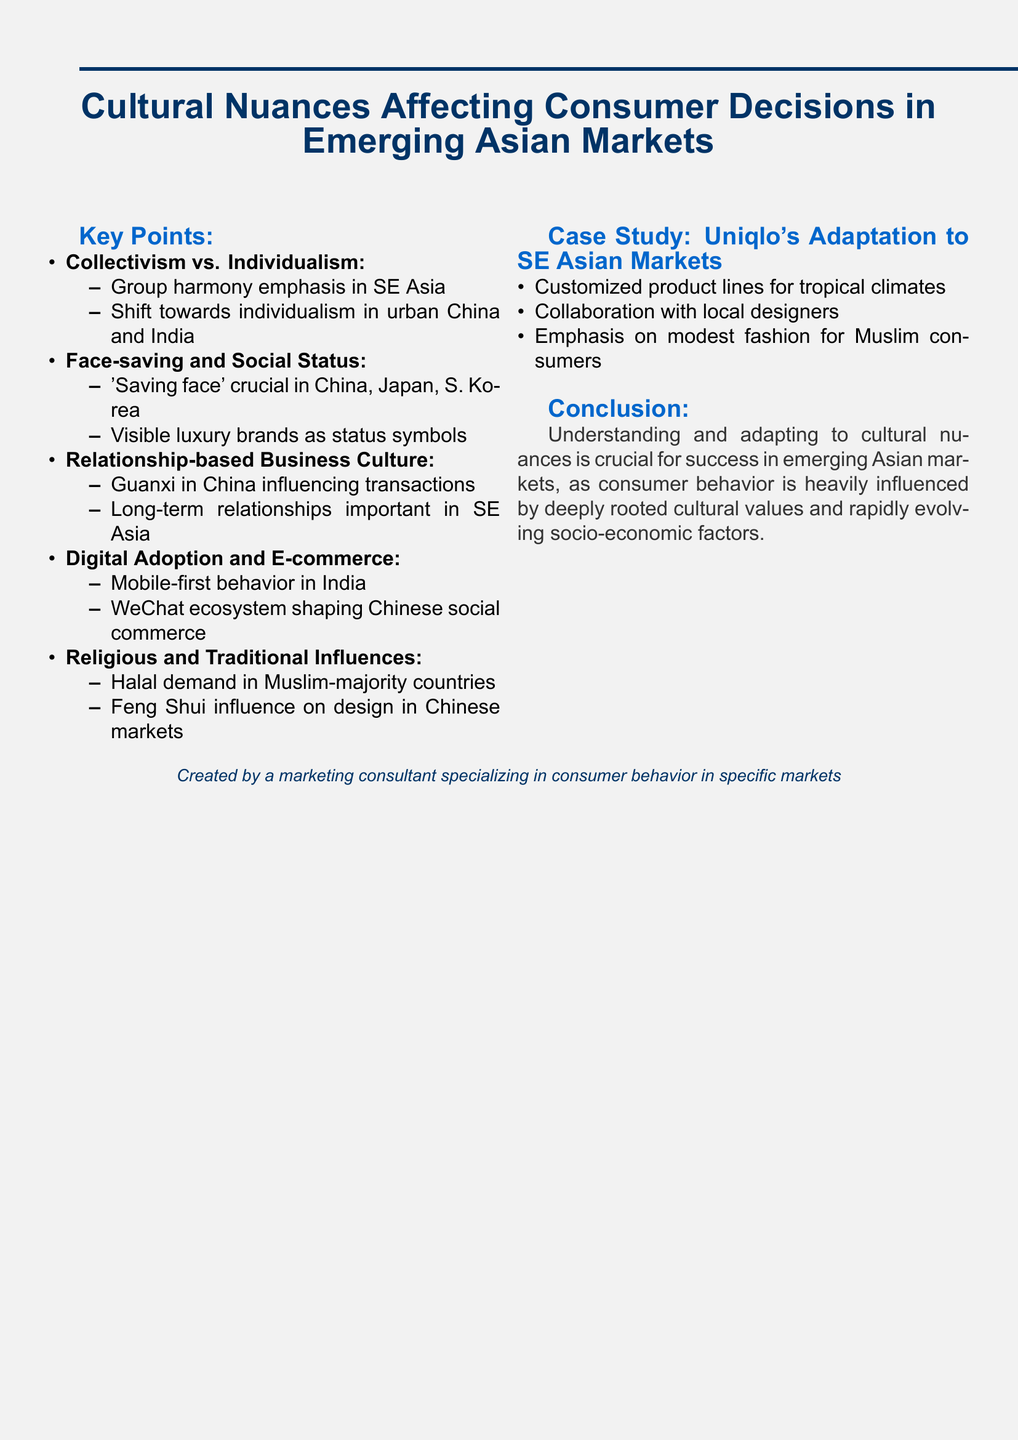what is the title of the document? The title is clearly stated at the beginning of the document, summarizing its focus on cultural aspects in consumer behavior.
Answer: Cultural Nuances Affecting Consumer Decisions in Emerging Asian Markets which countries emphasize group harmony? The document specifies particular regions where group harmony is a key cultural aspect that influences behavior, namely Southeast Asian countries.
Answer: Indonesia and Vietnam what does 'saving face' refer to? 'Saving face' refers to the importance of maintaining social dignity and honor, particularly highlighted in specific cultural contexts within the document.
Answer: importance of 'saving face' what does guanxi influence in China? Guanxi is a critical concept in Chinese culture mentioned in the document, affecting various types of transactions and relationships in business.
Answer: B2B and B2C transactions what is a significant factor in mobile-first behavior in India? The document notes a specific technological advancement affecting consumer habits, which is a relevant aspect when discussing mobile-first strategies.
Answer: rapid smartphone adoption what are Uniqlo's adaptations for Southeast Asian markets? The document provides detailed context on Uniqlo's business strategies that adapt to local cultural needs and consumer preferences in the region.
Answer: Customized product lines for tropical climates how does the WeChat ecosystem influence consumer behavior? This question requires understanding the implications of a specific digital platform's integration in shaping consumer habits, as mentioned in the document.
Answer: shaping social commerce trends what is the conclusion of the document? The conclusion precisely sums up the key takeaway about cultural understanding's role in market success, emphasizing its importance based on document content.
Answer: Understanding and adapting to cultural nuances is crucial for success in emerging Asian markets 